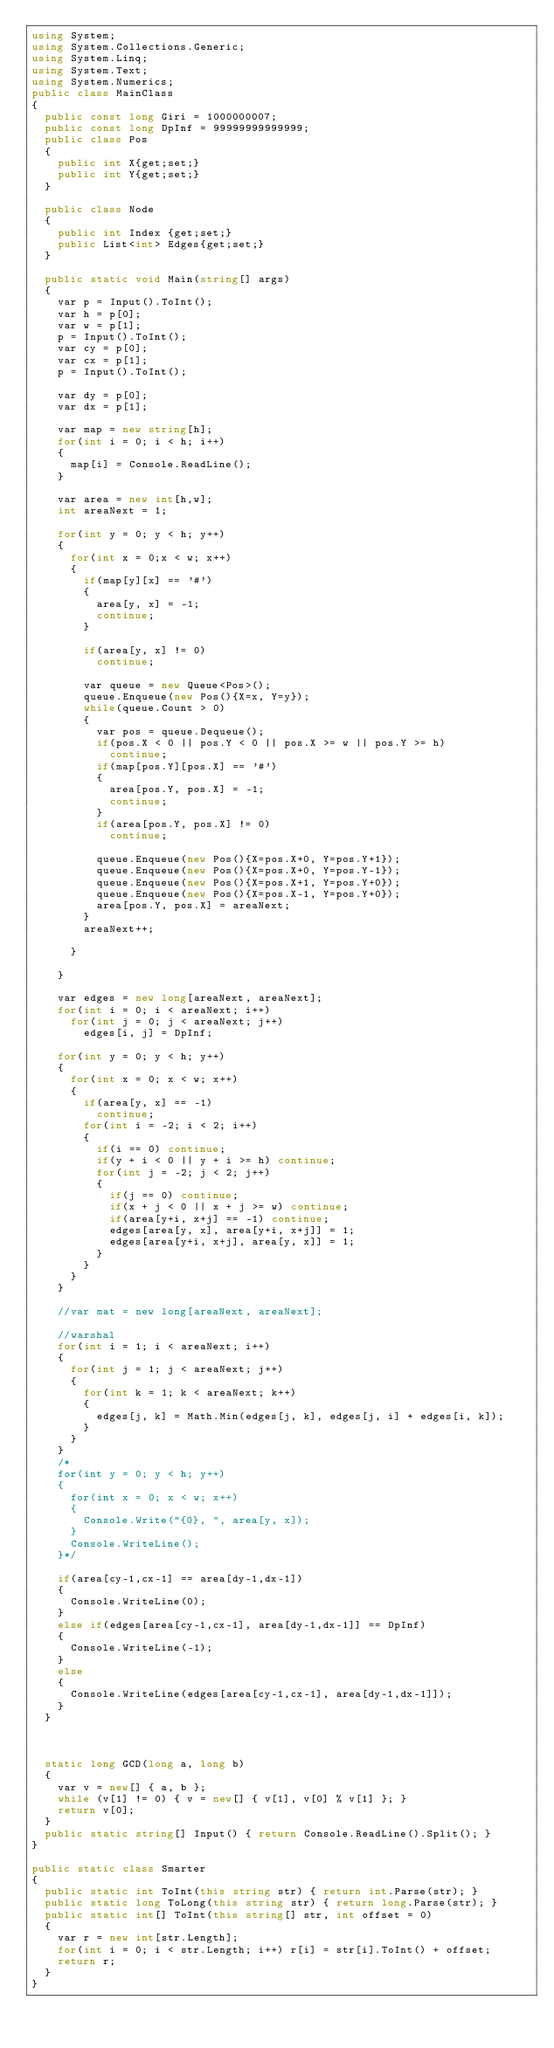Convert code to text. <code><loc_0><loc_0><loc_500><loc_500><_C#_>using System;
using System.Collections.Generic;
using System.Linq;
using System.Text;
using System.Numerics;
public class MainClass
{
	public const long Giri = 1000000007;
	public const long DpInf = 99999999999999;
	public class Pos
	{
		public int X{get;set;}
		public int Y{get;set;}
	}
	
	public class Node
	{
		public int Index {get;set;}
		public List<int> Edges{get;set;}
	}
	
	public static void Main(string[] args)
	{
		var p = Input().ToInt();
		var h = p[0];
		var w = p[1];
		p = Input().ToInt();
		var cy = p[0];
		var cx = p[1];
		p = Input().ToInt();
		
		var dy = p[0];
		var dx = p[1];
		
		var map = new string[h];
		for(int i = 0; i < h; i++)
		{
			map[i] = Console.ReadLine();
		}

		var area = new int[h,w];
		int areaNext = 1;
		
		for(int y = 0; y < h; y++)
		{
			for(int x = 0;x < w; x++)
			{
				if(map[y][x] == '#')
				{
					area[y, x] = -1;
					continue;
				}
				
				if(area[y, x] != 0)
					continue;
				
				var queue = new Queue<Pos>();
				queue.Enqueue(new Pos(){X=x, Y=y});
				while(queue.Count > 0)
				{
					var pos = queue.Dequeue();
					if(pos.X < 0 || pos.Y < 0 || pos.X >= w || pos.Y >= h)
						continue;
					if(map[pos.Y][pos.X] == '#')
					{
						area[pos.Y, pos.X] = -1;
						continue;
					}
					if(area[pos.Y, pos.X] != 0)
						continue;
						
					queue.Enqueue(new Pos(){X=pos.X+0, Y=pos.Y+1});
					queue.Enqueue(new Pos(){X=pos.X+0, Y=pos.Y-1});
					queue.Enqueue(new Pos(){X=pos.X+1, Y=pos.Y+0});
					queue.Enqueue(new Pos(){X=pos.X-1, Y=pos.Y+0});
					area[pos.Y, pos.X] = areaNext;
				}
				areaNext++;
				
			}
			
		}
		
		var edges = new long[areaNext, areaNext];
		for(int i = 0; i < areaNext; i++)
			for(int j = 0; j < areaNext; j++)
				edges[i, j] = DpInf;
		
		for(int y = 0; y < h; y++)
		{
			for(int x = 0; x < w; x++)
			{
				if(area[y, x] == -1)
					continue;
				for(int i = -2; i < 2; i++)
				{
					if(i == 0) continue;
					if(y + i < 0 || y + i >= h) continue;
					for(int j = -2; j < 2; j++)
					{
						if(j == 0) continue;
						if(x + j < 0 || x + j >= w) continue;
						if(area[y+i, x+j] == -1) continue;
						edges[area[y, x], area[y+i, x+j]] = 1;
						edges[area[y+i, x+j], area[y, x]] = 1;
					}
				}
			}
		}
		
		//var mat = new long[areaNext, areaNext];
		
		//warshal
		for(int i = 1; i < areaNext; i++)
		{
			for(int j = 1; j < areaNext; j++)
			{
				for(int k = 1; k < areaNext; k++)
				{
					edges[j, k] = Math.Min(edges[j, k], edges[j, i] + edges[i, k]);
				}
			}
		}
		/*
		for(int y = 0; y < h; y++)
		{
			for(int x = 0; x < w; x++)
			{
				Console.Write("{0}, ", area[y, x]);
			}
			Console.WriteLine();
		}*/
		
		if(area[cy-1,cx-1] == area[dy-1,dx-1])
		{
			Console.WriteLine(0);
		}
		else if(edges[area[cy-1,cx-1], area[dy-1,dx-1]] == DpInf)
		{
			Console.WriteLine(-1);
		}
		else
		{
			Console.WriteLine(edges[area[cy-1,cx-1], area[dy-1,dx-1]]);
		}
	}

	
	
	static long GCD(long a, long b)
	{
		var v = new[] { a, b };
		while (v[1] != 0) { v = new[] { v[1], v[0] % v[1] }; }
		return v[0];
	}
	public static string[] Input() { return Console.ReadLine().Split(); }
}

public static class Smarter
{
	public static int ToInt(this string str) { return int.Parse(str); }
	public static long ToLong(this string str) { return long.Parse(str); }
	public static int[] ToInt(this string[] str, int offset = 0)
	{
		var r = new int[str.Length];
		for(int i = 0; i < str.Length; i++) r[i] = str[i].ToInt() + offset;
		return r;
	}
}
</code> 